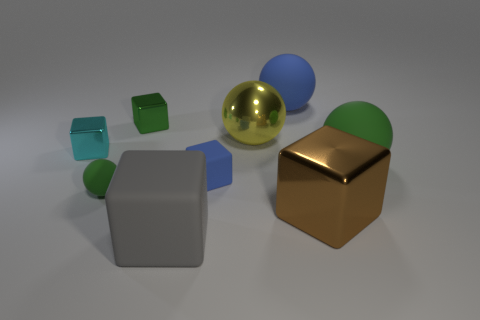What number of matte things are brown objects or yellow balls?
Keep it short and to the point. 0. There is a small rubber thing that is the same shape as the large gray thing; what color is it?
Your response must be concise. Blue. Is there a large yellow metal sphere?
Ensure brevity in your answer.  Yes. Do the green ball to the right of the big brown block and the cube right of the big blue matte sphere have the same material?
Make the answer very short. No. The large object that is the same color as the tiny rubber block is what shape?
Your answer should be compact. Sphere. How many things are green matte balls that are right of the large gray cube or cubes that are in front of the cyan metallic cube?
Your answer should be very brief. 4. Does the tiny block that is on the right side of the big gray object have the same color as the big rubber object behind the green shiny cube?
Make the answer very short. Yes. The green object that is in front of the large yellow thing and left of the small blue matte thing has what shape?
Ensure brevity in your answer.  Sphere. There is a metal block that is the same size as the blue matte sphere; what is its color?
Provide a succinct answer. Brown. Is there a cube that has the same color as the small rubber sphere?
Make the answer very short. Yes. 